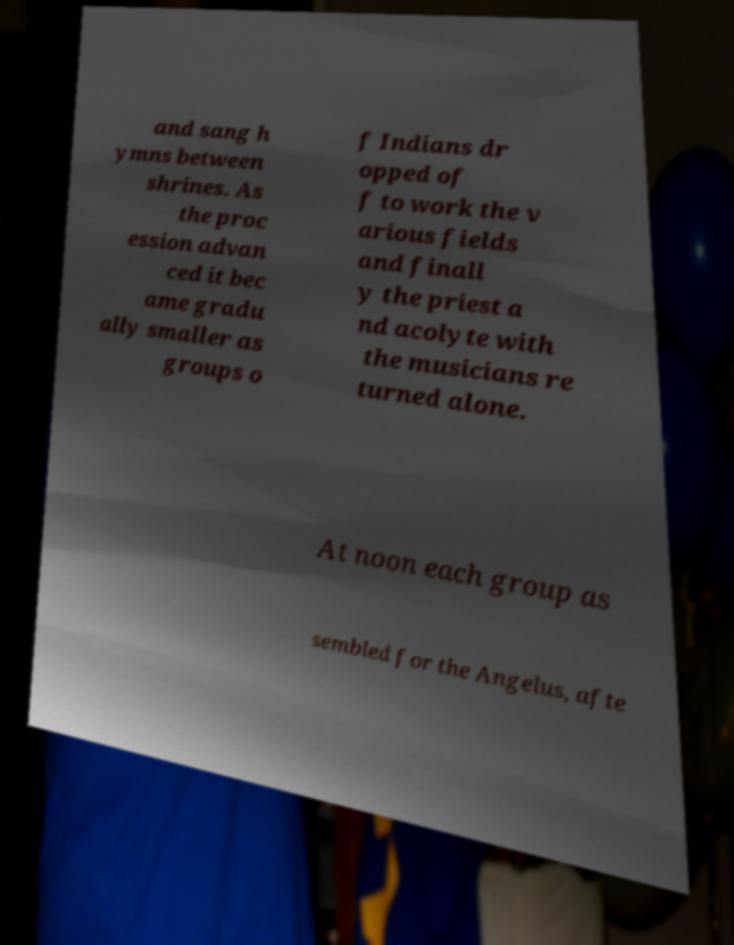Please identify and transcribe the text found in this image. and sang h ymns between shrines. As the proc ession advan ced it bec ame gradu ally smaller as groups o f Indians dr opped of f to work the v arious fields and finall y the priest a nd acolyte with the musicians re turned alone. At noon each group as sembled for the Angelus, afte 